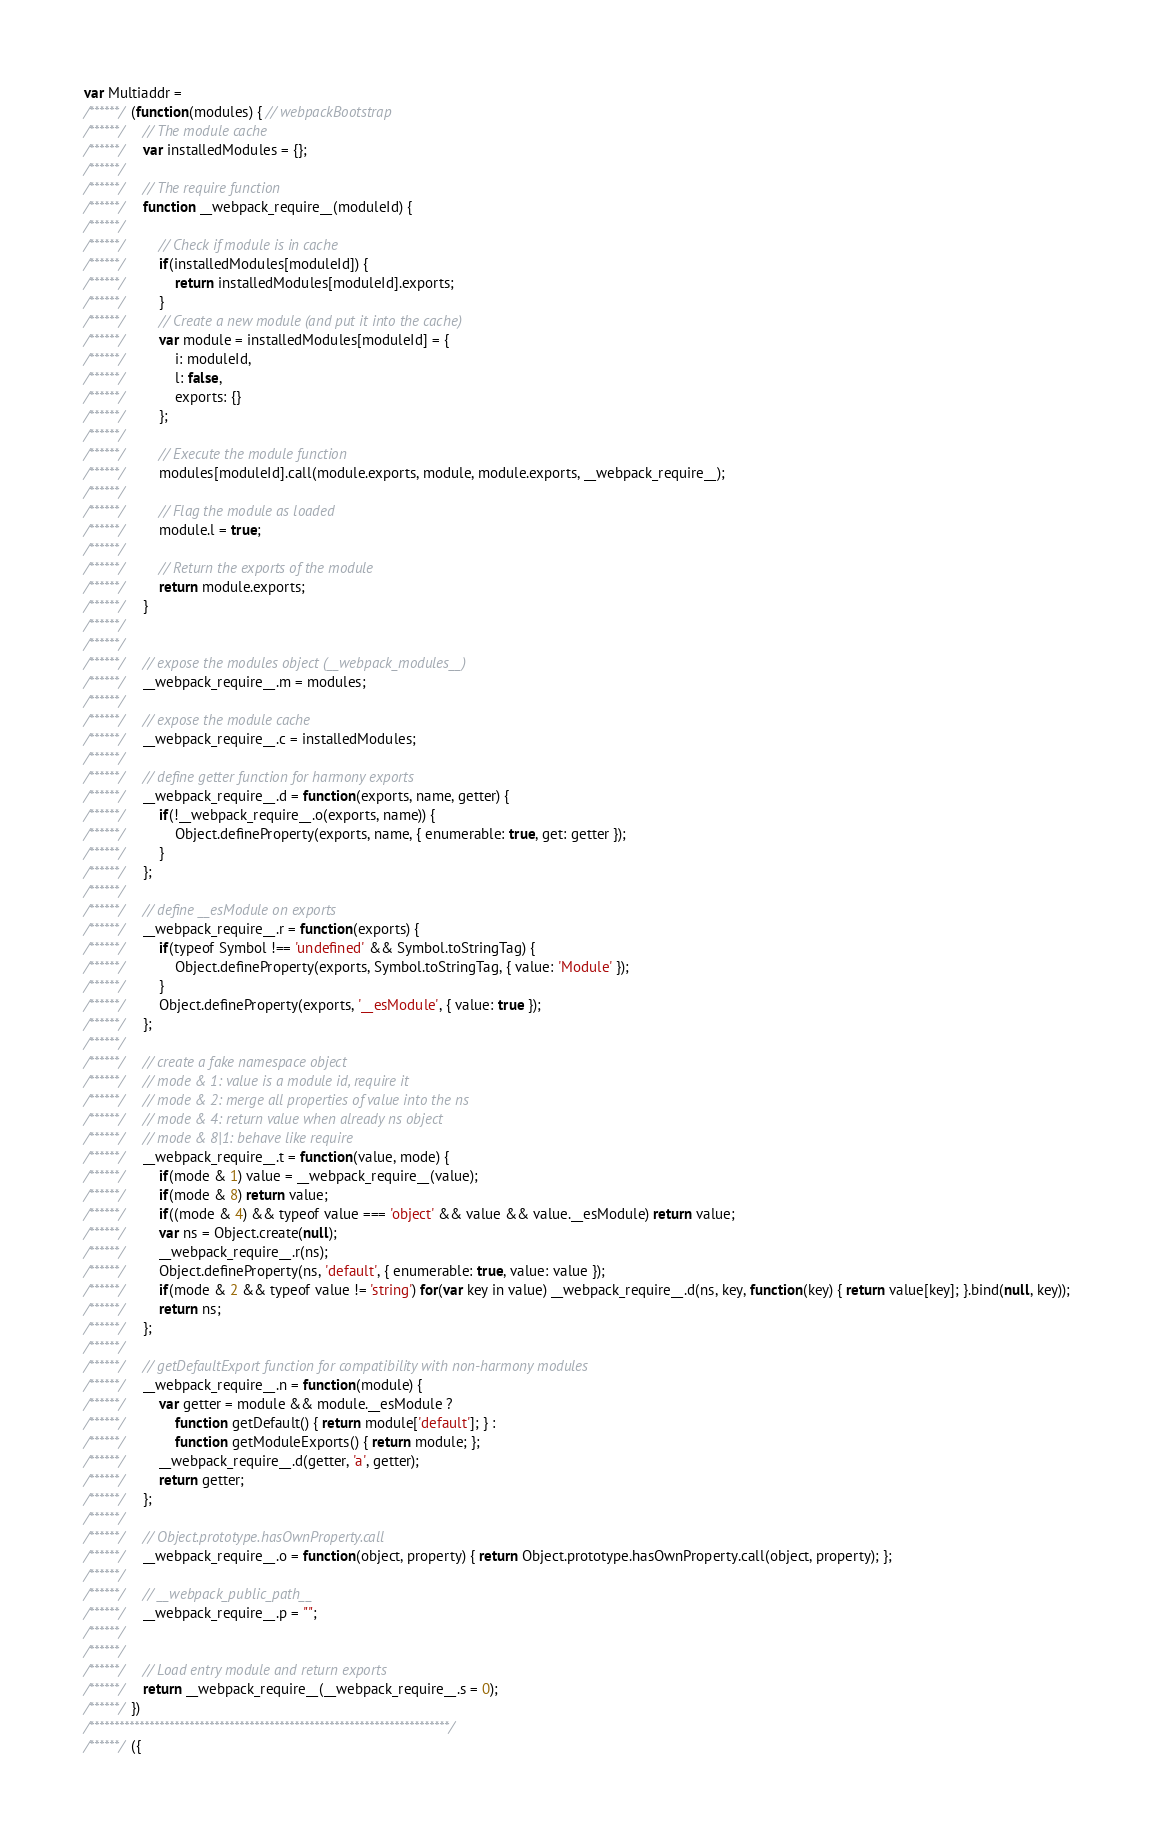<code> <loc_0><loc_0><loc_500><loc_500><_JavaScript_>var Multiaddr =
/******/ (function(modules) { // webpackBootstrap
/******/ 	// The module cache
/******/ 	var installedModules = {};
/******/
/******/ 	// The require function
/******/ 	function __webpack_require__(moduleId) {
/******/
/******/ 		// Check if module is in cache
/******/ 		if(installedModules[moduleId]) {
/******/ 			return installedModules[moduleId].exports;
/******/ 		}
/******/ 		// Create a new module (and put it into the cache)
/******/ 		var module = installedModules[moduleId] = {
/******/ 			i: moduleId,
/******/ 			l: false,
/******/ 			exports: {}
/******/ 		};
/******/
/******/ 		// Execute the module function
/******/ 		modules[moduleId].call(module.exports, module, module.exports, __webpack_require__);
/******/
/******/ 		// Flag the module as loaded
/******/ 		module.l = true;
/******/
/******/ 		// Return the exports of the module
/******/ 		return module.exports;
/******/ 	}
/******/
/******/
/******/ 	// expose the modules object (__webpack_modules__)
/******/ 	__webpack_require__.m = modules;
/******/
/******/ 	// expose the module cache
/******/ 	__webpack_require__.c = installedModules;
/******/
/******/ 	// define getter function for harmony exports
/******/ 	__webpack_require__.d = function(exports, name, getter) {
/******/ 		if(!__webpack_require__.o(exports, name)) {
/******/ 			Object.defineProperty(exports, name, { enumerable: true, get: getter });
/******/ 		}
/******/ 	};
/******/
/******/ 	// define __esModule on exports
/******/ 	__webpack_require__.r = function(exports) {
/******/ 		if(typeof Symbol !== 'undefined' && Symbol.toStringTag) {
/******/ 			Object.defineProperty(exports, Symbol.toStringTag, { value: 'Module' });
/******/ 		}
/******/ 		Object.defineProperty(exports, '__esModule', { value: true });
/******/ 	};
/******/
/******/ 	// create a fake namespace object
/******/ 	// mode & 1: value is a module id, require it
/******/ 	// mode & 2: merge all properties of value into the ns
/******/ 	// mode & 4: return value when already ns object
/******/ 	// mode & 8|1: behave like require
/******/ 	__webpack_require__.t = function(value, mode) {
/******/ 		if(mode & 1) value = __webpack_require__(value);
/******/ 		if(mode & 8) return value;
/******/ 		if((mode & 4) && typeof value === 'object' && value && value.__esModule) return value;
/******/ 		var ns = Object.create(null);
/******/ 		__webpack_require__.r(ns);
/******/ 		Object.defineProperty(ns, 'default', { enumerable: true, value: value });
/******/ 		if(mode & 2 && typeof value != 'string') for(var key in value) __webpack_require__.d(ns, key, function(key) { return value[key]; }.bind(null, key));
/******/ 		return ns;
/******/ 	};
/******/
/******/ 	// getDefaultExport function for compatibility with non-harmony modules
/******/ 	__webpack_require__.n = function(module) {
/******/ 		var getter = module && module.__esModule ?
/******/ 			function getDefault() { return module['default']; } :
/******/ 			function getModuleExports() { return module; };
/******/ 		__webpack_require__.d(getter, 'a', getter);
/******/ 		return getter;
/******/ 	};
/******/
/******/ 	// Object.prototype.hasOwnProperty.call
/******/ 	__webpack_require__.o = function(object, property) { return Object.prototype.hasOwnProperty.call(object, property); };
/******/
/******/ 	// __webpack_public_path__
/******/ 	__webpack_require__.p = "";
/******/
/******/
/******/ 	// Load entry module and return exports
/******/ 	return __webpack_require__(__webpack_require__.s = 0);
/******/ })
/************************************************************************/
/******/ ({
</code> 